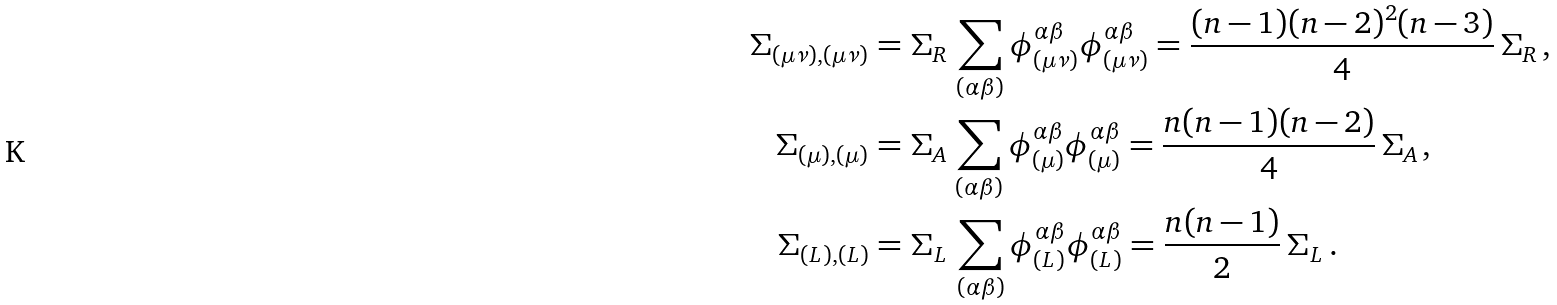<formula> <loc_0><loc_0><loc_500><loc_500>\Sigma _ { ( \mu \nu ) , ( \mu \nu ) } & = \Sigma _ { R } \, \sum _ { ( \alpha \beta ) } \phi ^ { \alpha \beta } _ { ( \mu \nu ) } \phi ^ { \alpha \beta } _ { ( \mu \nu ) } = \frac { ( n - 1 ) ( n - 2 ) ^ { 2 } ( n - 3 ) } { 4 } \, \Sigma _ { R } \, , \\ \Sigma _ { ( \mu ) , ( \mu ) } & = \Sigma _ { A } \, \sum _ { ( \alpha \beta ) } \phi ^ { \alpha \beta } _ { ( \mu ) } \phi ^ { \alpha \beta } _ { ( \mu ) } = \frac { n ( n - 1 ) ( n - 2 ) } { 4 } \, \Sigma _ { A } \, , \\ \Sigma _ { ( L ) , ( L ) } & = \Sigma _ { L } \, \sum _ { ( \alpha \beta ) } \phi ^ { \alpha \beta } _ { ( L ) } \phi ^ { \alpha \beta } _ { ( L ) } = \frac { n ( n - 1 ) } { 2 } \, \Sigma _ { L } \, .</formula> 